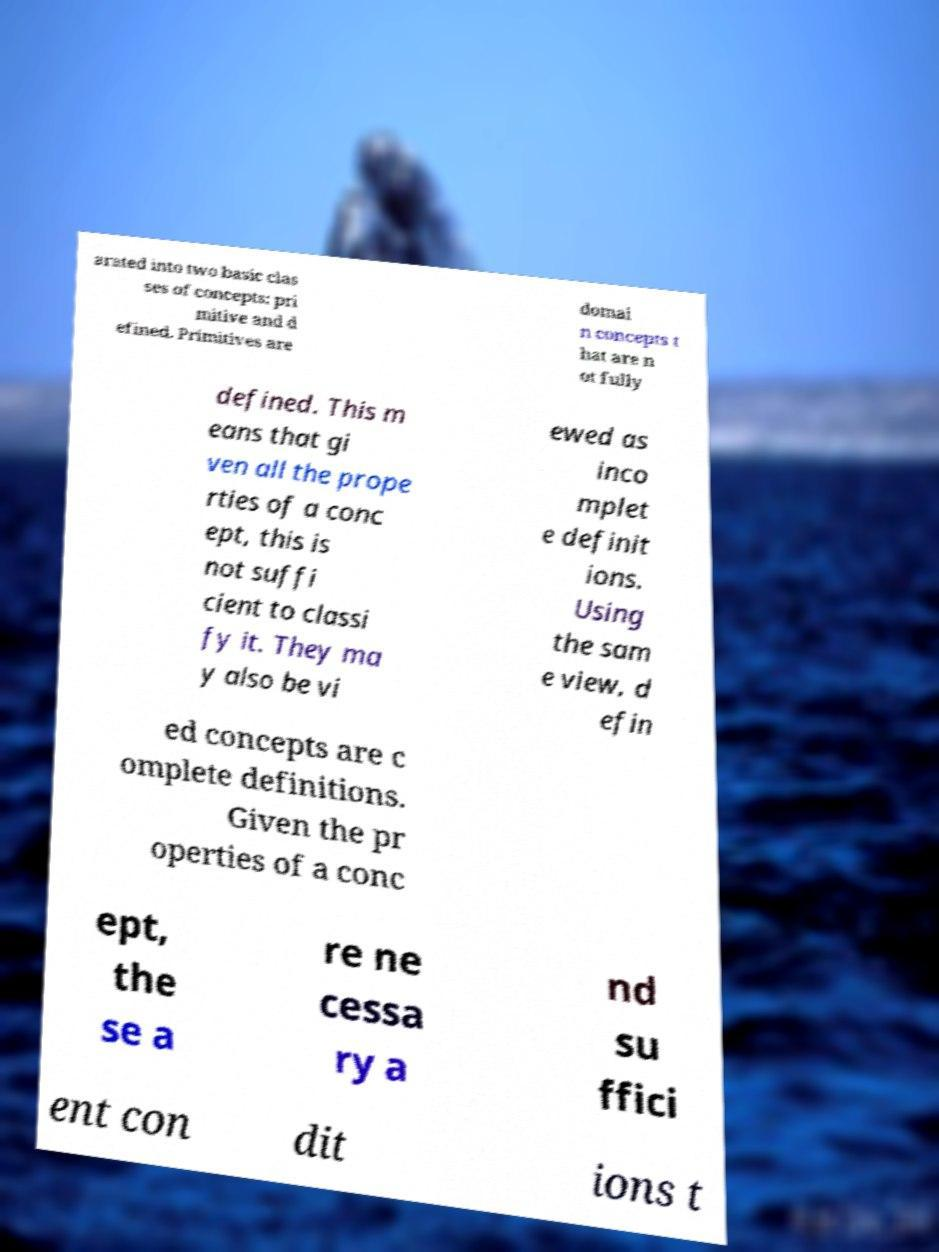Could you extract and type out the text from this image? arated into two basic clas ses of concepts: pri mitive and d efined. Primitives are domai n concepts t hat are n ot fully defined. This m eans that gi ven all the prope rties of a conc ept, this is not suffi cient to classi fy it. They ma y also be vi ewed as inco mplet e definit ions. Using the sam e view, d efin ed concepts are c omplete definitions. Given the pr operties of a conc ept, the se a re ne cessa ry a nd su ffici ent con dit ions t 